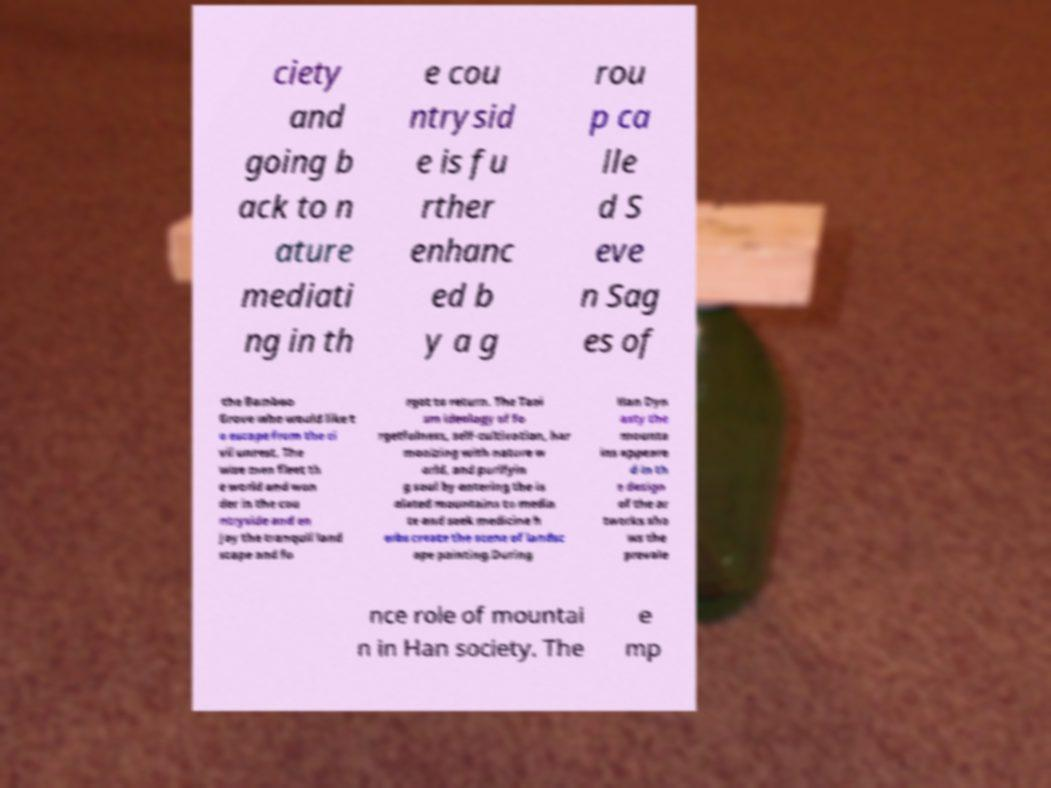For documentation purposes, I need the text within this image transcribed. Could you provide that? ciety and going b ack to n ature mediati ng in th e cou ntrysid e is fu rther enhanc ed b y a g rou p ca lle d S eve n Sag es of the Bamboo Grove who would like t o escape from the ci vil unrest. The wise men fleet th e world and won der in the cou ntryside and en joy the tranquil land scape and fo rgot to return. The Taoi sm ideology of fo rgetfulness, self-cultivation, har monizing with nature w orld, and purifyin g soul by entering the is olated mountains to media te and seek medicine h erbs create the scene of landsc ape painting.During Han Dyn asty the mounta ins appeare d in th e design of the ar tworks sho ws the prevale nce role of mountai n in Han society. The e mp 